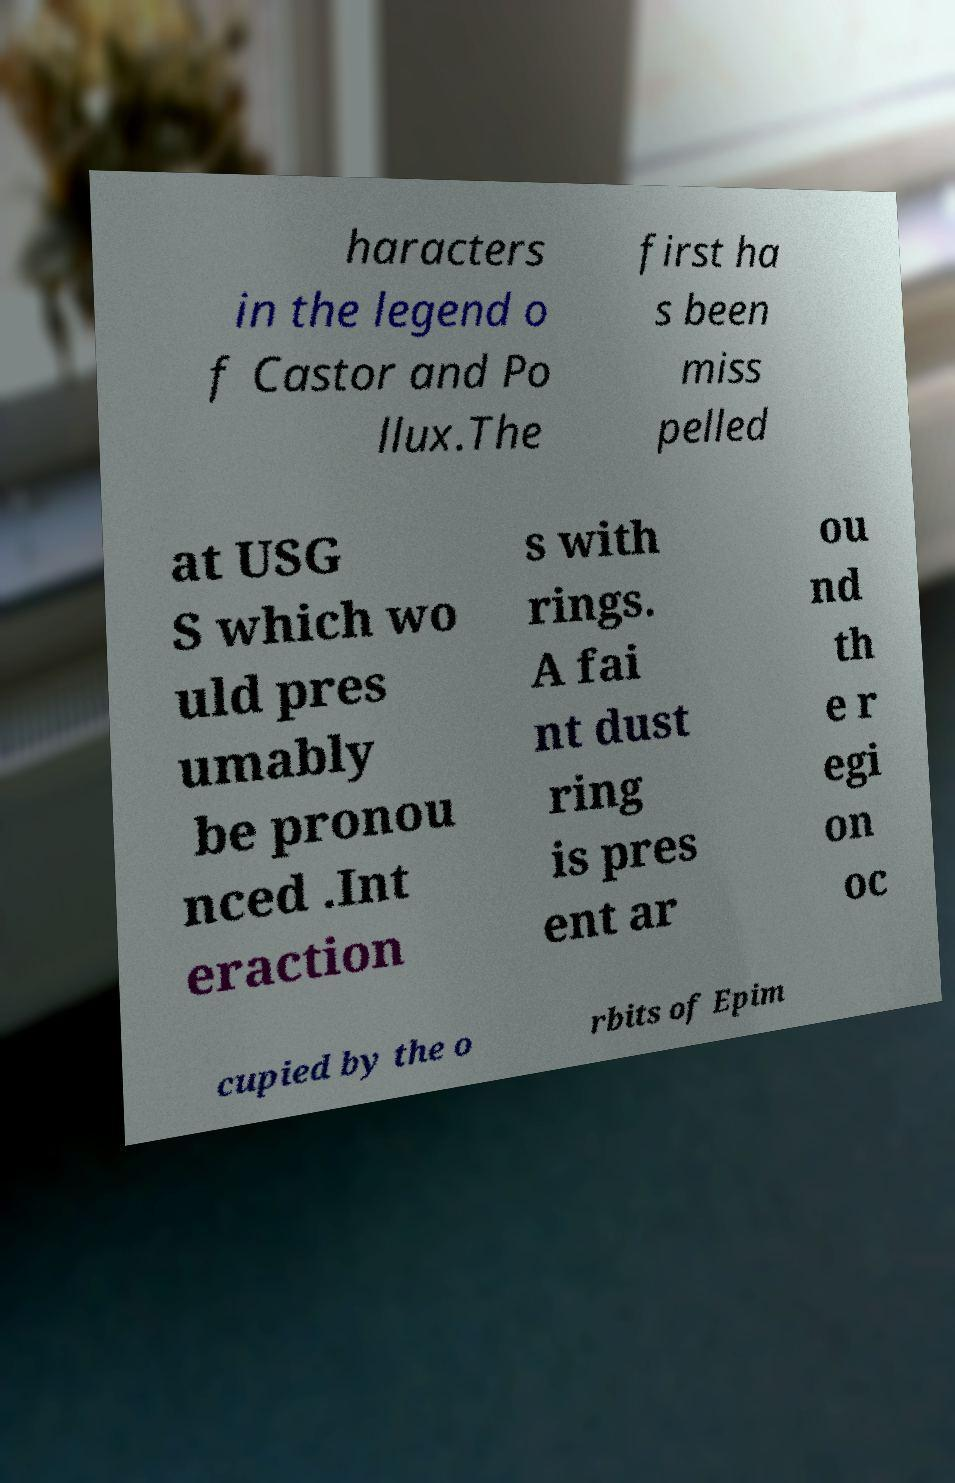Could you extract and type out the text from this image? haracters in the legend o f Castor and Po llux.The first ha s been miss pelled at USG S which wo uld pres umably be pronou nced .Int eraction s with rings. A fai nt dust ring is pres ent ar ou nd th e r egi on oc cupied by the o rbits of Epim 